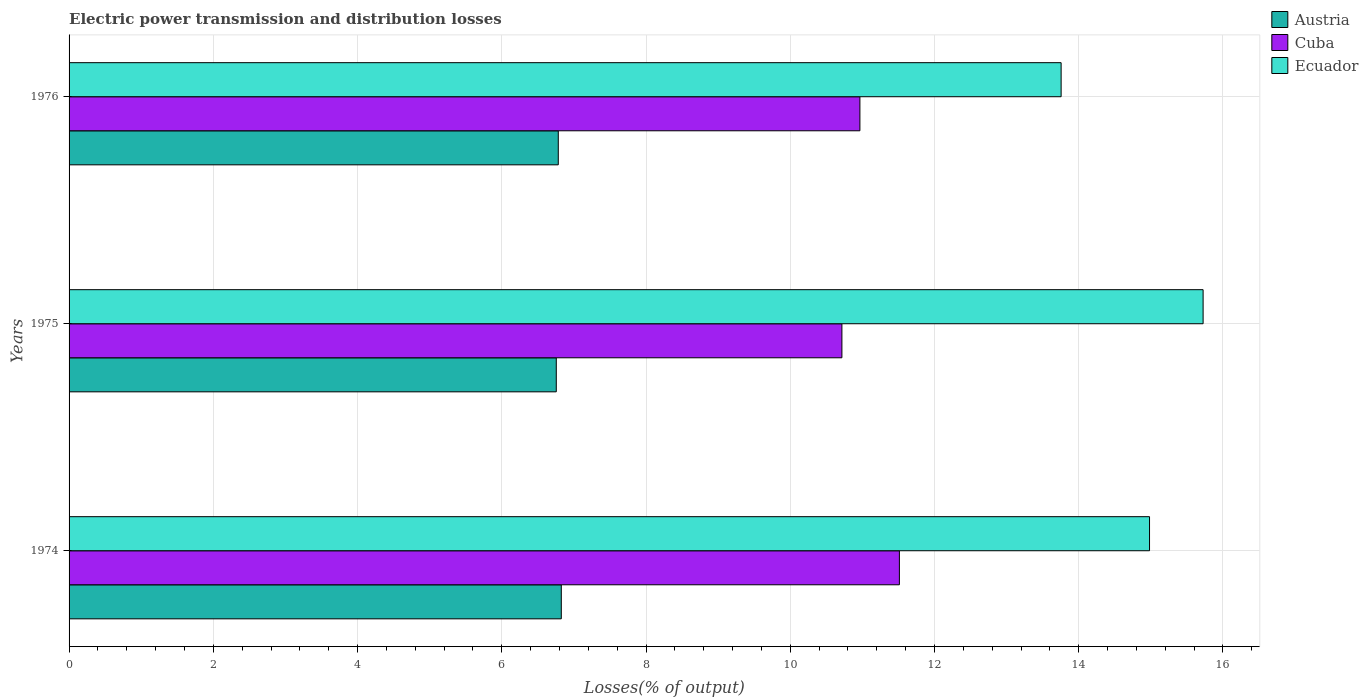How many different coloured bars are there?
Give a very brief answer. 3. How many bars are there on the 3rd tick from the bottom?
Your answer should be very brief. 3. What is the label of the 3rd group of bars from the top?
Provide a short and direct response. 1974. What is the electric power transmission and distribution losses in Austria in 1975?
Provide a succinct answer. 6.76. Across all years, what is the maximum electric power transmission and distribution losses in Cuba?
Your answer should be compact. 11.51. Across all years, what is the minimum electric power transmission and distribution losses in Austria?
Your response must be concise. 6.76. In which year was the electric power transmission and distribution losses in Austria maximum?
Your answer should be compact. 1974. In which year was the electric power transmission and distribution losses in Cuba minimum?
Offer a terse response. 1975. What is the total electric power transmission and distribution losses in Ecuador in the graph?
Your answer should be compact. 44.46. What is the difference between the electric power transmission and distribution losses in Austria in 1974 and that in 1975?
Provide a succinct answer. 0.07. What is the difference between the electric power transmission and distribution losses in Cuba in 1976 and the electric power transmission and distribution losses in Austria in 1974?
Your answer should be very brief. 4.14. What is the average electric power transmission and distribution losses in Austria per year?
Keep it short and to the point. 6.79. In the year 1974, what is the difference between the electric power transmission and distribution losses in Ecuador and electric power transmission and distribution losses in Cuba?
Make the answer very short. 3.47. What is the ratio of the electric power transmission and distribution losses in Cuba in 1975 to that in 1976?
Keep it short and to the point. 0.98. What is the difference between the highest and the second highest electric power transmission and distribution losses in Ecuador?
Provide a succinct answer. 0.74. What is the difference between the highest and the lowest electric power transmission and distribution losses in Cuba?
Ensure brevity in your answer.  0.8. In how many years, is the electric power transmission and distribution losses in Austria greater than the average electric power transmission and distribution losses in Austria taken over all years?
Provide a short and direct response. 1. What does the 1st bar from the top in 1976 represents?
Provide a short and direct response. Ecuador. Is it the case that in every year, the sum of the electric power transmission and distribution losses in Cuba and electric power transmission and distribution losses in Ecuador is greater than the electric power transmission and distribution losses in Austria?
Your answer should be compact. Yes. How many bars are there?
Your answer should be compact. 9. What is the difference between two consecutive major ticks on the X-axis?
Your answer should be compact. 2. Are the values on the major ticks of X-axis written in scientific E-notation?
Make the answer very short. No. Does the graph contain grids?
Give a very brief answer. Yes. Where does the legend appear in the graph?
Your response must be concise. Top right. How many legend labels are there?
Keep it short and to the point. 3. How are the legend labels stacked?
Make the answer very short. Vertical. What is the title of the graph?
Make the answer very short. Electric power transmission and distribution losses. What is the label or title of the X-axis?
Ensure brevity in your answer.  Losses(% of output). What is the label or title of the Y-axis?
Your answer should be compact. Years. What is the Losses(% of output) of Austria in 1974?
Provide a succinct answer. 6.83. What is the Losses(% of output) in Cuba in 1974?
Provide a short and direct response. 11.51. What is the Losses(% of output) in Ecuador in 1974?
Give a very brief answer. 14.98. What is the Losses(% of output) of Austria in 1975?
Your answer should be very brief. 6.76. What is the Losses(% of output) of Cuba in 1975?
Offer a terse response. 10.72. What is the Losses(% of output) in Ecuador in 1975?
Give a very brief answer. 15.72. What is the Losses(% of output) in Austria in 1976?
Give a very brief answer. 6.78. What is the Losses(% of output) of Cuba in 1976?
Keep it short and to the point. 10.97. What is the Losses(% of output) of Ecuador in 1976?
Make the answer very short. 13.76. Across all years, what is the maximum Losses(% of output) of Austria?
Ensure brevity in your answer.  6.83. Across all years, what is the maximum Losses(% of output) of Cuba?
Make the answer very short. 11.51. Across all years, what is the maximum Losses(% of output) of Ecuador?
Your response must be concise. 15.72. Across all years, what is the minimum Losses(% of output) in Austria?
Provide a short and direct response. 6.76. Across all years, what is the minimum Losses(% of output) of Cuba?
Provide a short and direct response. 10.72. Across all years, what is the minimum Losses(% of output) of Ecuador?
Ensure brevity in your answer.  13.76. What is the total Losses(% of output) in Austria in the graph?
Provide a short and direct response. 20.36. What is the total Losses(% of output) of Cuba in the graph?
Your answer should be compact. 33.2. What is the total Losses(% of output) of Ecuador in the graph?
Ensure brevity in your answer.  44.46. What is the difference between the Losses(% of output) in Austria in 1974 and that in 1975?
Provide a short and direct response. 0.07. What is the difference between the Losses(% of output) of Cuba in 1974 and that in 1975?
Give a very brief answer. 0.8. What is the difference between the Losses(% of output) in Ecuador in 1974 and that in 1975?
Provide a succinct answer. -0.74. What is the difference between the Losses(% of output) in Austria in 1974 and that in 1976?
Provide a succinct answer. 0.04. What is the difference between the Losses(% of output) in Cuba in 1974 and that in 1976?
Give a very brief answer. 0.55. What is the difference between the Losses(% of output) in Ecuador in 1974 and that in 1976?
Give a very brief answer. 1.23. What is the difference between the Losses(% of output) of Austria in 1975 and that in 1976?
Offer a very short reply. -0.03. What is the difference between the Losses(% of output) in Cuba in 1975 and that in 1976?
Provide a short and direct response. -0.25. What is the difference between the Losses(% of output) of Ecuador in 1975 and that in 1976?
Provide a succinct answer. 1.97. What is the difference between the Losses(% of output) in Austria in 1974 and the Losses(% of output) in Cuba in 1975?
Make the answer very short. -3.89. What is the difference between the Losses(% of output) of Austria in 1974 and the Losses(% of output) of Ecuador in 1975?
Offer a very short reply. -8.9. What is the difference between the Losses(% of output) in Cuba in 1974 and the Losses(% of output) in Ecuador in 1975?
Your response must be concise. -4.21. What is the difference between the Losses(% of output) of Austria in 1974 and the Losses(% of output) of Cuba in 1976?
Keep it short and to the point. -4.14. What is the difference between the Losses(% of output) of Austria in 1974 and the Losses(% of output) of Ecuador in 1976?
Give a very brief answer. -6.93. What is the difference between the Losses(% of output) of Cuba in 1974 and the Losses(% of output) of Ecuador in 1976?
Your response must be concise. -2.24. What is the difference between the Losses(% of output) in Austria in 1975 and the Losses(% of output) in Cuba in 1976?
Offer a very short reply. -4.21. What is the difference between the Losses(% of output) of Austria in 1975 and the Losses(% of output) of Ecuador in 1976?
Make the answer very short. -7. What is the difference between the Losses(% of output) of Cuba in 1975 and the Losses(% of output) of Ecuador in 1976?
Ensure brevity in your answer.  -3.04. What is the average Losses(% of output) in Austria per year?
Give a very brief answer. 6.79. What is the average Losses(% of output) of Cuba per year?
Your answer should be very brief. 11.07. What is the average Losses(% of output) of Ecuador per year?
Keep it short and to the point. 14.82. In the year 1974, what is the difference between the Losses(% of output) of Austria and Losses(% of output) of Cuba?
Keep it short and to the point. -4.69. In the year 1974, what is the difference between the Losses(% of output) of Austria and Losses(% of output) of Ecuador?
Your response must be concise. -8.16. In the year 1974, what is the difference between the Losses(% of output) of Cuba and Losses(% of output) of Ecuador?
Your answer should be very brief. -3.47. In the year 1975, what is the difference between the Losses(% of output) in Austria and Losses(% of output) in Cuba?
Your answer should be compact. -3.96. In the year 1975, what is the difference between the Losses(% of output) in Austria and Losses(% of output) in Ecuador?
Make the answer very short. -8.97. In the year 1975, what is the difference between the Losses(% of output) in Cuba and Losses(% of output) in Ecuador?
Your response must be concise. -5.01. In the year 1976, what is the difference between the Losses(% of output) in Austria and Losses(% of output) in Cuba?
Give a very brief answer. -4.18. In the year 1976, what is the difference between the Losses(% of output) in Austria and Losses(% of output) in Ecuador?
Give a very brief answer. -6.97. In the year 1976, what is the difference between the Losses(% of output) in Cuba and Losses(% of output) in Ecuador?
Give a very brief answer. -2.79. What is the ratio of the Losses(% of output) in Austria in 1974 to that in 1975?
Your response must be concise. 1.01. What is the ratio of the Losses(% of output) in Cuba in 1974 to that in 1975?
Give a very brief answer. 1.07. What is the ratio of the Losses(% of output) of Ecuador in 1974 to that in 1975?
Your answer should be compact. 0.95. What is the ratio of the Losses(% of output) in Austria in 1974 to that in 1976?
Provide a succinct answer. 1.01. What is the ratio of the Losses(% of output) in Cuba in 1974 to that in 1976?
Your response must be concise. 1.05. What is the ratio of the Losses(% of output) of Ecuador in 1974 to that in 1976?
Give a very brief answer. 1.09. What is the ratio of the Losses(% of output) in Cuba in 1975 to that in 1976?
Provide a short and direct response. 0.98. What is the ratio of the Losses(% of output) in Ecuador in 1975 to that in 1976?
Give a very brief answer. 1.14. What is the difference between the highest and the second highest Losses(% of output) of Austria?
Your answer should be very brief. 0.04. What is the difference between the highest and the second highest Losses(% of output) in Cuba?
Your response must be concise. 0.55. What is the difference between the highest and the second highest Losses(% of output) of Ecuador?
Offer a very short reply. 0.74. What is the difference between the highest and the lowest Losses(% of output) in Austria?
Make the answer very short. 0.07. What is the difference between the highest and the lowest Losses(% of output) in Cuba?
Your answer should be very brief. 0.8. What is the difference between the highest and the lowest Losses(% of output) of Ecuador?
Your answer should be very brief. 1.97. 